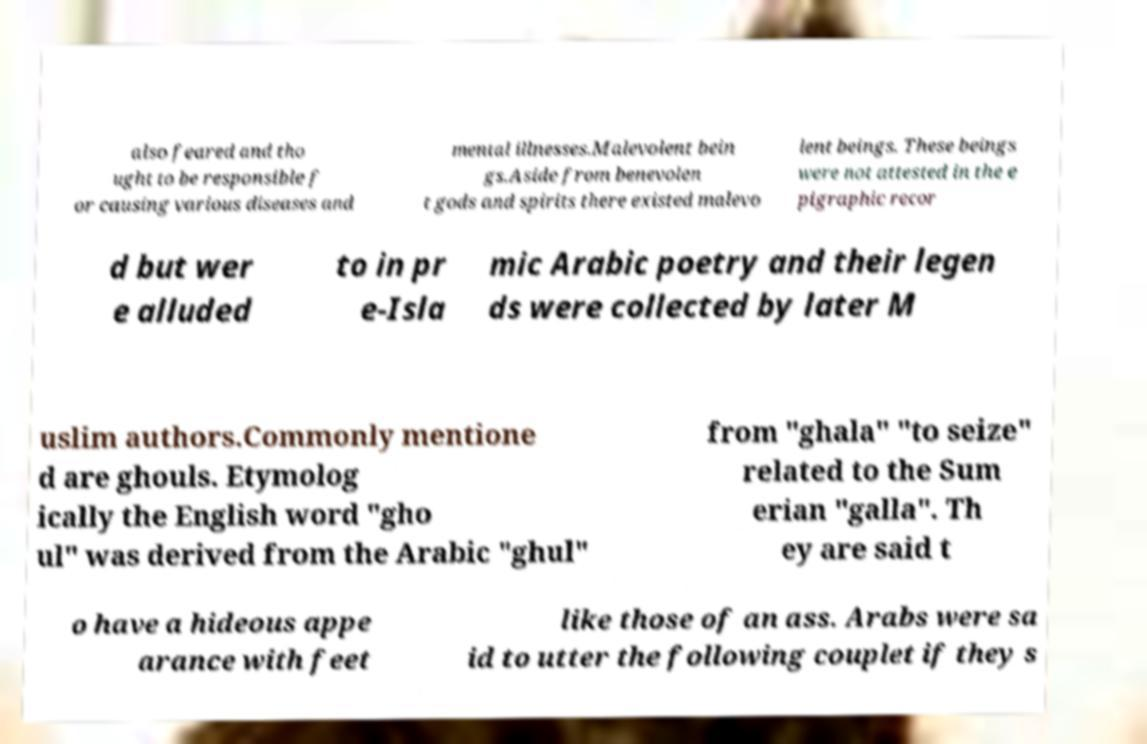What messages or text are displayed in this image? I need them in a readable, typed format. also feared and tho ught to be responsible f or causing various diseases and mental illnesses.Malevolent bein gs.Aside from benevolen t gods and spirits there existed malevo lent beings. These beings were not attested in the e pigraphic recor d but wer e alluded to in pr e-Isla mic Arabic poetry and their legen ds were collected by later M uslim authors.Commonly mentione d are ghouls. Etymolog ically the English word "gho ul" was derived from the Arabic "ghul" from "ghala" "to seize" related to the Sum erian "galla". Th ey are said t o have a hideous appe arance with feet like those of an ass. Arabs were sa id to utter the following couplet if they s 